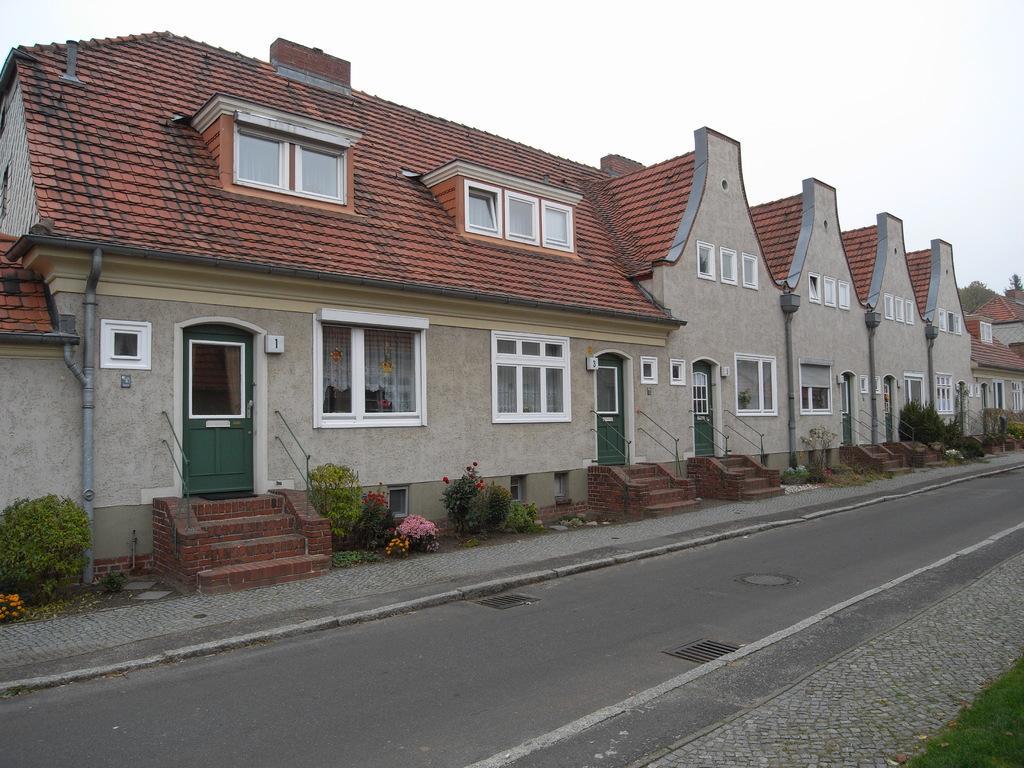How would you summarize this image in a sentence or two? In this image we can see there is the building and there are stairs, in front of the building we can see the road and grass. And there are plants, flowers, trees and the sky. 